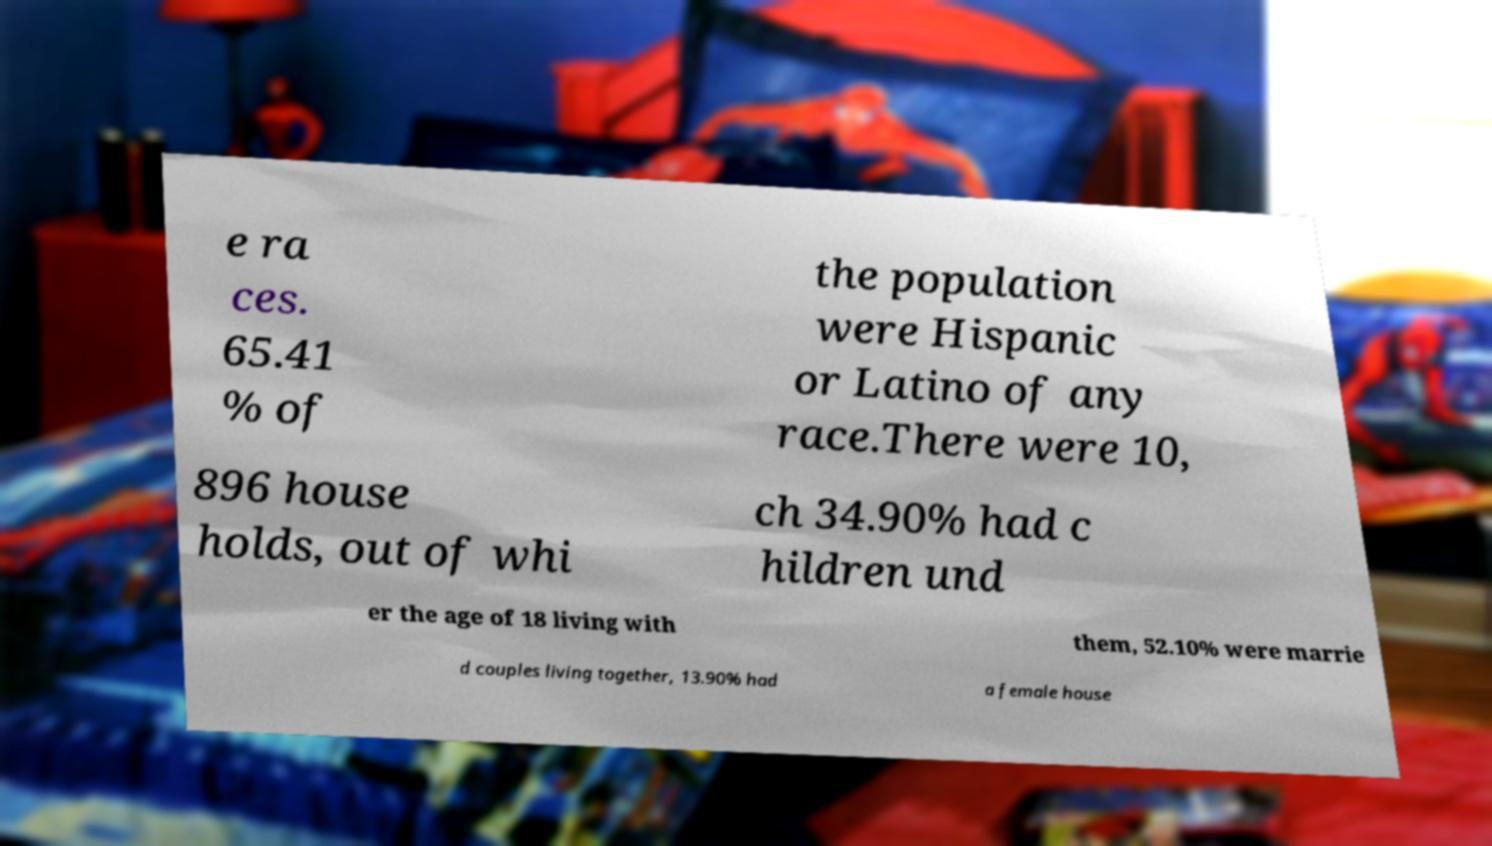Can you read and provide the text displayed in the image?This photo seems to have some interesting text. Can you extract and type it out for me? e ra ces. 65.41 % of the population were Hispanic or Latino of any race.There were 10, 896 house holds, out of whi ch 34.90% had c hildren und er the age of 18 living with them, 52.10% were marrie d couples living together, 13.90% had a female house 